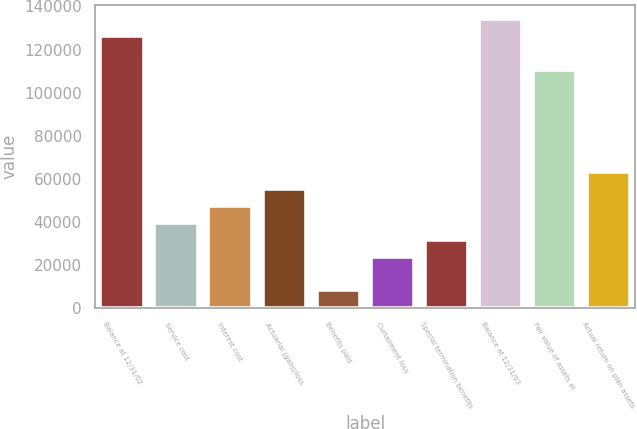Convert chart to OTSL. <chart><loc_0><loc_0><loc_500><loc_500><bar_chart><fcel>Balance at 12/31/02<fcel>Service cost<fcel>Interest cost<fcel>Actuarial (gain)/loss<fcel>Benefits paid<fcel>Curtailment loss<fcel>Special termination benefits<fcel>Balance at 12/31/03<fcel>Fair value of assets at<fcel>Actual return on plan assets<nl><fcel>126241<fcel>39693<fcel>47561<fcel>55429<fcel>8221<fcel>23957<fcel>31825<fcel>134109<fcel>110505<fcel>63297<nl></chart> 